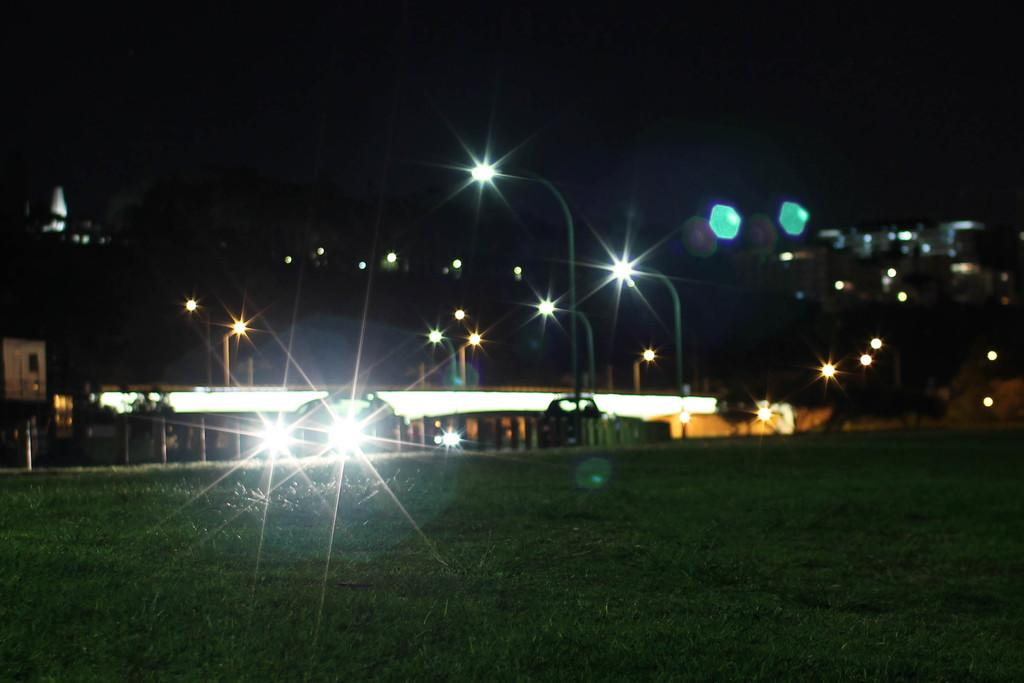What is the main subject of the image? The main subject of the image is a car. What other objects can be seen in the image? There are street lights and a building visible in the image. What type of terrain is at the bottom of the image? The bottom of the image contains grassy land. What type of dinner is being served in the window of the building? There is no window or dinner present in the image; it only features a car, street lights, a building, and grassy land. 